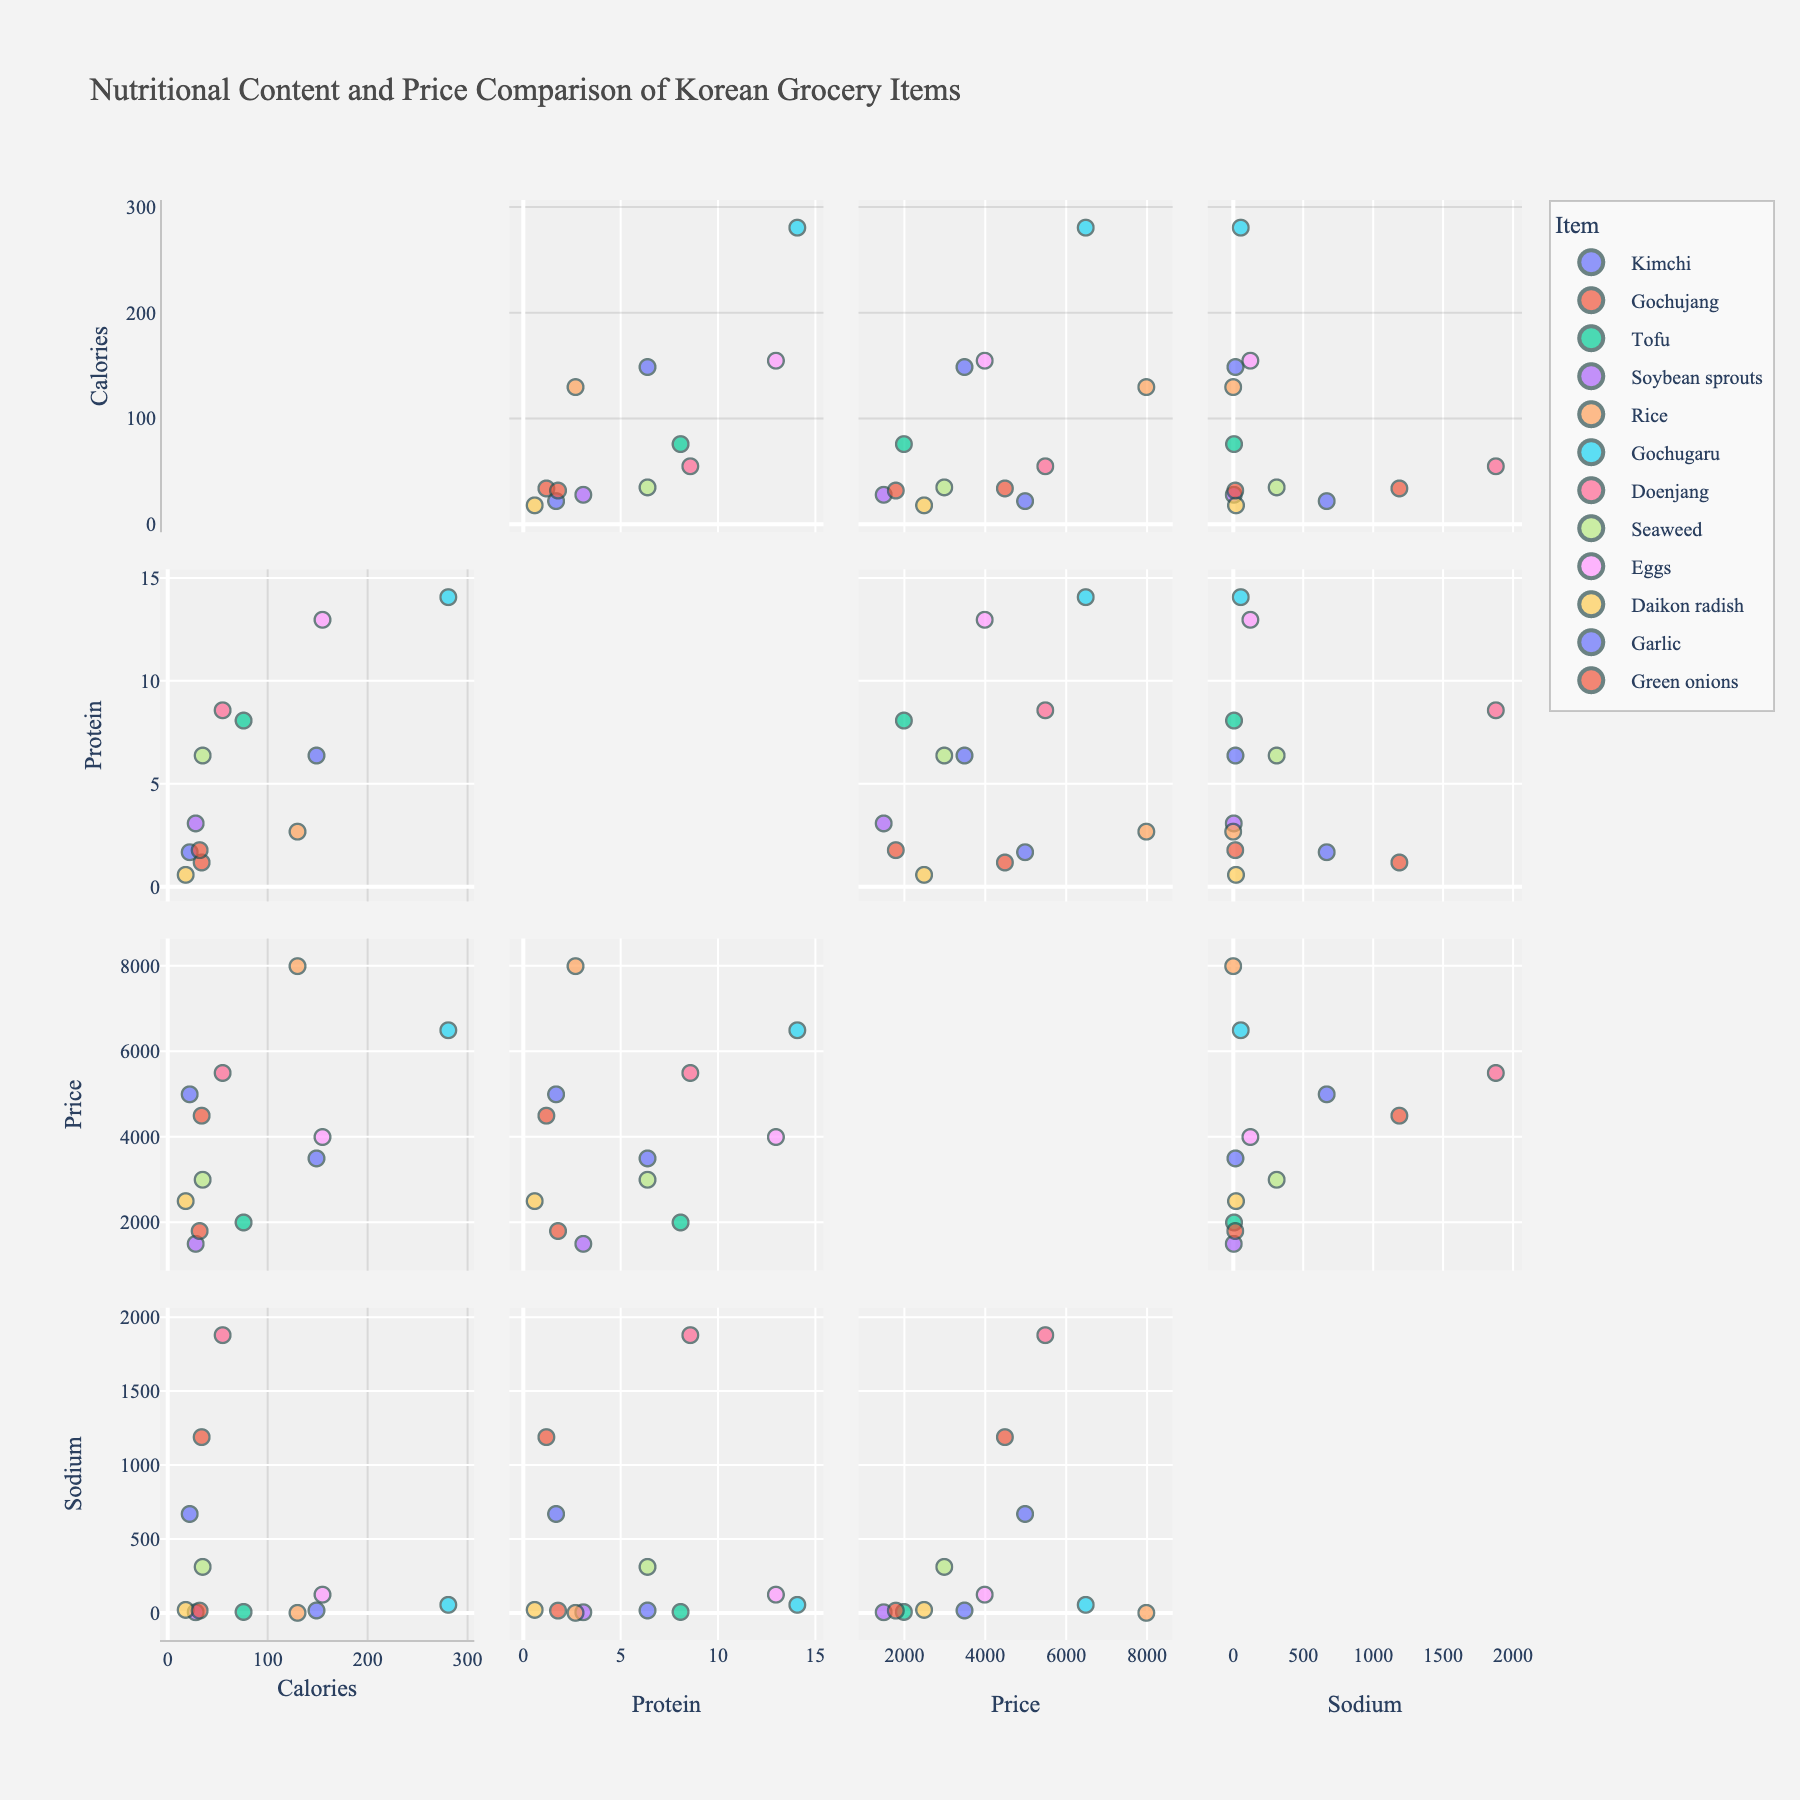What is the title of the scatterplot matrix? The title is usually located at the top of the figure. Here, it would be clearly visible as "Nutritional Content and Price Comparison of Korean Grocery Items".
Answer: Nutritional Content and Price Comparison of Korean Grocery Items How many data points are displayed in the scatterplot matrix? Each item in the data represents a data point. Given 12 items in the data, there are 12 data points in the scatterplot matrix.
Answer: 12 Which item has the highest protein content? By looking at the Protein (g) axis, you can identify the point that corresponds to the highest value. Gochugaru has the highest protein content at 14.1g.
Answer: Gochugaru Which item contains the most Sodium (mg)? By observing the extreme points on the Sodium (mg) axis, you'll find that Doenjang has the highest sodium content at 1880 mg.
Answer: Doenjang Is there an item that has both low Sodium (mg) and low Calories? Review the plot sections where Sodium and Calories are both plotted. Soybean sprouts and Daikon radish have low values in both categories.
Answer: Yes, Soybean sprouts and Daikon radish Which item is the most expensive based on Price (KRW)? Identify the data point with the highest value on the Price (KRW) axis. Rice, priced at 8000 KRW, is the most expensive item.
Answer: Rice What is the total Calories from Kimchi and Tofu combined? Locate the Kimchi (22 Calories) and Tofu (76 Calories) points on the Calories axis, then sum these values: 22 + 76 = 98.
Answer: 98 Between Kimchi and Seaweed, which has higher protein content? Compare the Protein (g) values for both items: Kimchi (1.7g) and Seaweed (6.4g). Seaweed has higher protein.
Answer: Seaweed Which item has similar Sodium content to Eggs? Observe the Sodium (mg) values: Eggs have 124 mg. Seaweed (312 mg) and Garlic (17 mg) are closest to Eggs.
Answer: Seaweed Is there a clear correlation between Protein (g) and Price (KRW)? By evaluating the scatter plot area where Protein (g) intersects with Price (KRW), see if the trend is linear. There doesn't appear to be a clear correlation as prices vary widely for different protein values.
Answer: No, there's no clear correlation 